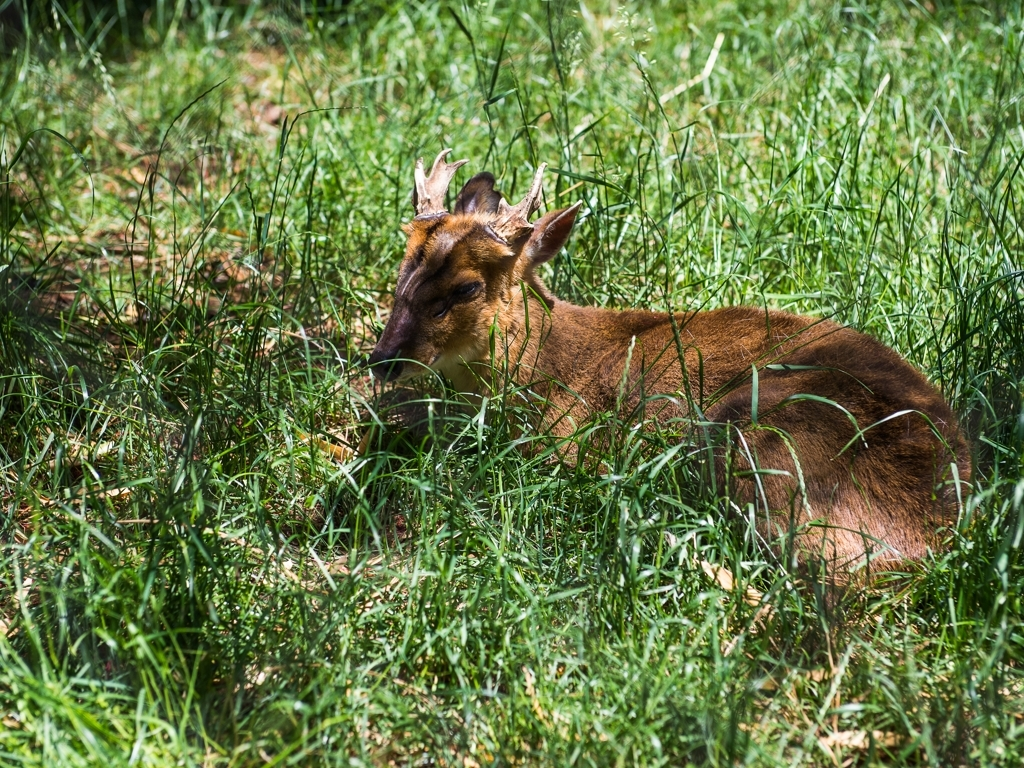Overall, what is the quality of this image?
A. Outstanding
B. Superior
C. Poor
Answer with the option's letter from the given choices directly. Evaluating the overall quality of the image, it appears to have good focus on the subject, a deer, with appropriate exposure and color balance. However, it doesn't stand out as exceptional in terms of composition or creativity, which could elevate it to 'Outstanding' or 'Superior.' Thus, a more fitting description for the quality would be 'Acceptable,' which was not an option provided. Given the provided choices, a more accurate assessment might have been 'B. Superior' as it is a clear image, despite not being outstanding. 